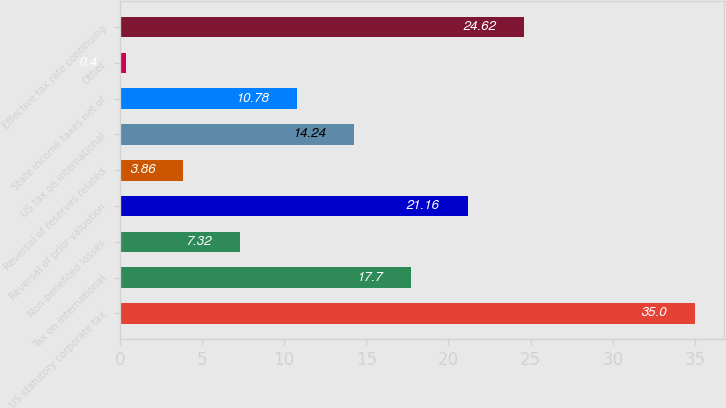Convert chart. <chart><loc_0><loc_0><loc_500><loc_500><bar_chart><fcel>US statutory corporate tax<fcel>Tax on international<fcel>Non-benefited losses<fcel>Reversal of prior valuation<fcel>Reversal of reserves related<fcel>US tax on international<fcel>State income taxes net of<fcel>Other<fcel>Effective tax rate continuing<nl><fcel>35<fcel>17.7<fcel>7.32<fcel>21.16<fcel>3.86<fcel>14.24<fcel>10.78<fcel>0.4<fcel>24.62<nl></chart> 